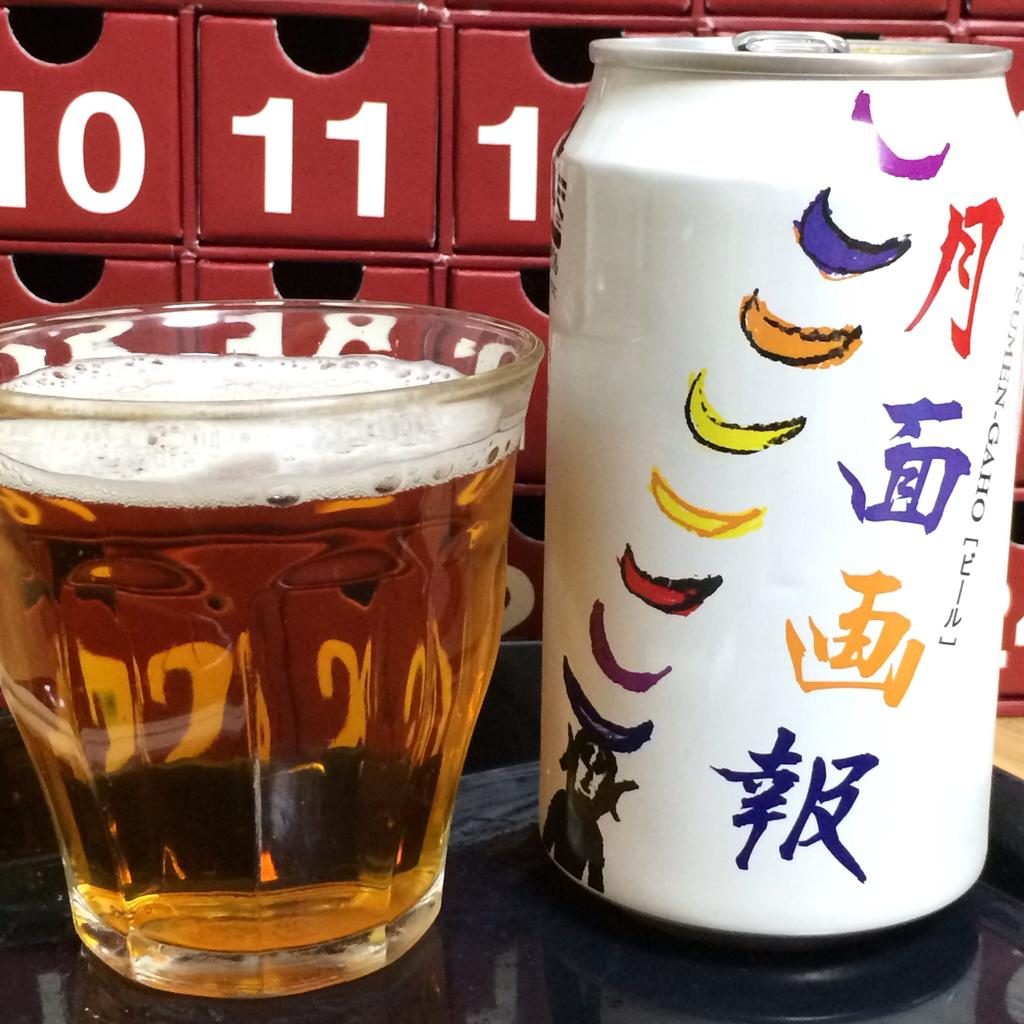<image>
Write a terse but informative summary of the picture. a white can with colorful moons on it in front of shelves with numbers 10 and 11 on them 